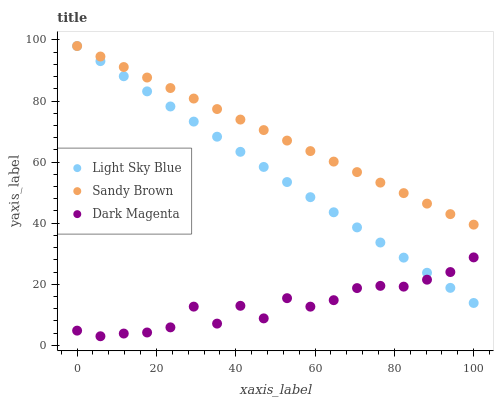Does Dark Magenta have the minimum area under the curve?
Answer yes or no. Yes. Does Sandy Brown have the maximum area under the curve?
Answer yes or no. Yes. Does Sandy Brown have the minimum area under the curve?
Answer yes or no. No. Does Dark Magenta have the maximum area under the curve?
Answer yes or no. No. Is Sandy Brown the smoothest?
Answer yes or no. Yes. Is Dark Magenta the roughest?
Answer yes or no. Yes. Is Dark Magenta the smoothest?
Answer yes or no. No. Is Sandy Brown the roughest?
Answer yes or no. No. Does Dark Magenta have the lowest value?
Answer yes or no. Yes. Does Sandy Brown have the lowest value?
Answer yes or no. No. Does Sandy Brown have the highest value?
Answer yes or no. Yes. Does Dark Magenta have the highest value?
Answer yes or no. No. Is Dark Magenta less than Sandy Brown?
Answer yes or no. Yes. Is Sandy Brown greater than Dark Magenta?
Answer yes or no. Yes. Does Sandy Brown intersect Light Sky Blue?
Answer yes or no. Yes. Is Sandy Brown less than Light Sky Blue?
Answer yes or no. No. Is Sandy Brown greater than Light Sky Blue?
Answer yes or no. No. Does Dark Magenta intersect Sandy Brown?
Answer yes or no. No. 